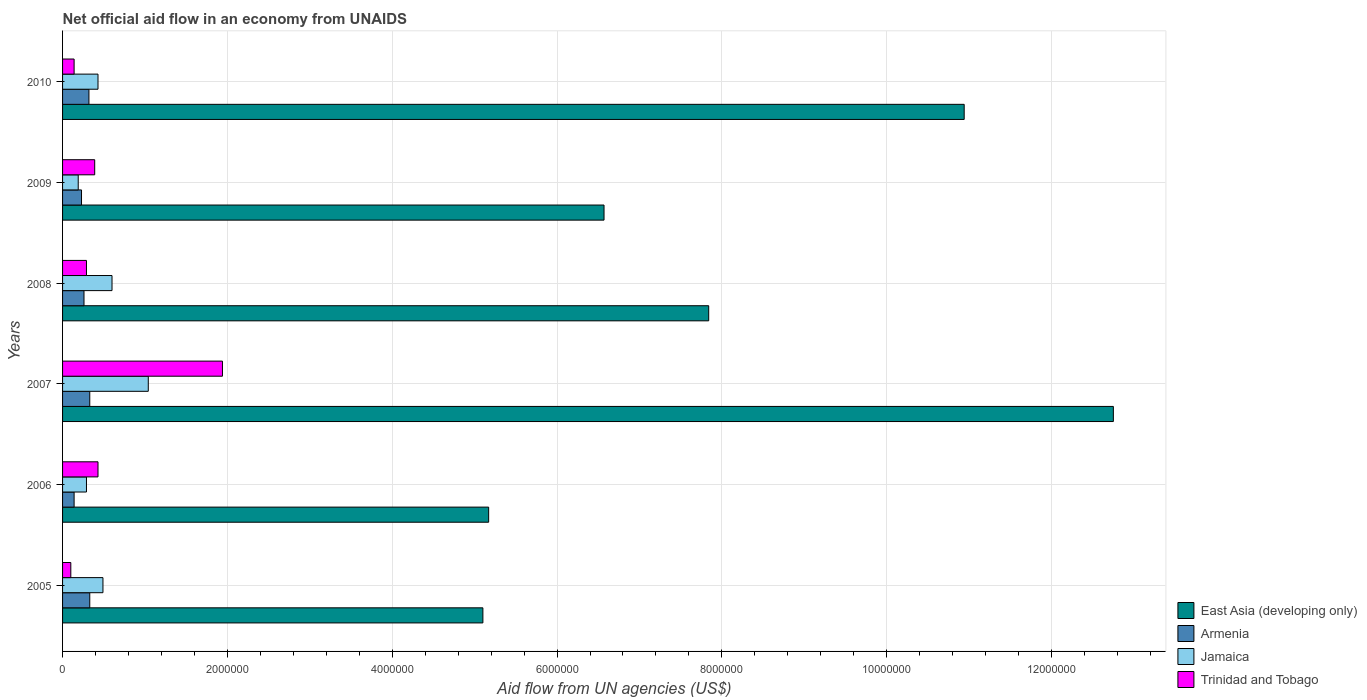How many different coloured bars are there?
Keep it short and to the point. 4. Are the number of bars per tick equal to the number of legend labels?
Provide a short and direct response. Yes. How many bars are there on the 2nd tick from the top?
Keep it short and to the point. 4. How many bars are there on the 5th tick from the bottom?
Keep it short and to the point. 4. In how many cases, is the number of bars for a given year not equal to the number of legend labels?
Your answer should be very brief. 0. Across all years, what is the maximum net official aid flow in Trinidad and Tobago?
Make the answer very short. 1.94e+06. Across all years, what is the minimum net official aid flow in Jamaica?
Provide a short and direct response. 1.90e+05. In which year was the net official aid flow in East Asia (developing only) minimum?
Provide a succinct answer. 2005. What is the total net official aid flow in Trinidad and Tobago in the graph?
Make the answer very short. 3.29e+06. What is the difference between the net official aid flow in Armenia in 2008 and that in 2010?
Provide a short and direct response. -6.00e+04. What is the difference between the net official aid flow in Jamaica in 2006 and the net official aid flow in Armenia in 2009?
Provide a short and direct response. 6.00e+04. What is the average net official aid flow in Trinidad and Tobago per year?
Make the answer very short. 5.48e+05. In the year 2010, what is the difference between the net official aid flow in Armenia and net official aid flow in East Asia (developing only)?
Your answer should be compact. -1.06e+07. In how many years, is the net official aid flow in Trinidad and Tobago greater than 6400000 US$?
Keep it short and to the point. 0. What is the ratio of the net official aid flow in East Asia (developing only) in 2006 to that in 2008?
Your answer should be very brief. 0.66. Is the net official aid flow in Armenia in 2007 less than that in 2010?
Your answer should be compact. No. Is the difference between the net official aid flow in Armenia in 2008 and 2010 greater than the difference between the net official aid flow in East Asia (developing only) in 2008 and 2010?
Give a very brief answer. Yes. What is the difference between the highest and the lowest net official aid flow in East Asia (developing only)?
Your answer should be compact. 7.65e+06. What does the 1st bar from the top in 2008 represents?
Your answer should be very brief. Trinidad and Tobago. What does the 2nd bar from the bottom in 2006 represents?
Give a very brief answer. Armenia. Is it the case that in every year, the sum of the net official aid flow in East Asia (developing only) and net official aid flow in Jamaica is greater than the net official aid flow in Trinidad and Tobago?
Provide a short and direct response. Yes. How many bars are there?
Your answer should be very brief. 24. What is the difference between two consecutive major ticks on the X-axis?
Offer a very short reply. 2.00e+06. Does the graph contain grids?
Your answer should be very brief. Yes. What is the title of the graph?
Keep it short and to the point. Net official aid flow in an economy from UNAIDS. What is the label or title of the X-axis?
Ensure brevity in your answer.  Aid flow from UN agencies (US$). What is the label or title of the Y-axis?
Your response must be concise. Years. What is the Aid flow from UN agencies (US$) in East Asia (developing only) in 2005?
Ensure brevity in your answer.  5.10e+06. What is the Aid flow from UN agencies (US$) in Armenia in 2005?
Provide a short and direct response. 3.30e+05. What is the Aid flow from UN agencies (US$) of Jamaica in 2005?
Provide a succinct answer. 4.90e+05. What is the Aid flow from UN agencies (US$) in East Asia (developing only) in 2006?
Make the answer very short. 5.17e+06. What is the Aid flow from UN agencies (US$) in Armenia in 2006?
Offer a very short reply. 1.40e+05. What is the Aid flow from UN agencies (US$) of East Asia (developing only) in 2007?
Offer a very short reply. 1.28e+07. What is the Aid flow from UN agencies (US$) in Jamaica in 2007?
Offer a very short reply. 1.04e+06. What is the Aid flow from UN agencies (US$) in Trinidad and Tobago in 2007?
Your answer should be compact. 1.94e+06. What is the Aid flow from UN agencies (US$) in East Asia (developing only) in 2008?
Your answer should be very brief. 7.84e+06. What is the Aid flow from UN agencies (US$) in Trinidad and Tobago in 2008?
Keep it short and to the point. 2.90e+05. What is the Aid flow from UN agencies (US$) of East Asia (developing only) in 2009?
Your answer should be compact. 6.57e+06. What is the Aid flow from UN agencies (US$) of Armenia in 2009?
Your answer should be very brief. 2.30e+05. What is the Aid flow from UN agencies (US$) in East Asia (developing only) in 2010?
Your answer should be compact. 1.09e+07. What is the Aid flow from UN agencies (US$) of Armenia in 2010?
Provide a short and direct response. 3.20e+05. What is the Aid flow from UN agencies (US$) of Jamaica in 2010?
Provide a succinct answer. 4.30e+05. What is the Aid flow from UN agencies (US$) of Trinidad and Tobago in 2010?
Ensure brevity in your answer.  1.40e+05. Across all years, what is the maximum Aid flow from UN agencies (US$) of East Asia (developing only)?
Give a very brief answer. 1.28e+07. Across all years, what is the maximum Aid flow from UN agencies (US$) of Jamaica?
Give a very brief answer. 1.04e+06. Across all years, what is the maximum Aid flow from UN agencies (US$) in Trinidad and Tobago?
Ensure brevity in your answer.  1.94e+06. Across all years, what is the minimum Aid flow from UN agencies (US$) in East Asia (developing only)?
Keep it short and to the point. 5.10e+06. Across all years, what is the minimum Aid flow from UN agencies (US$) of Trinidad and Tobago?
Ensure brevity in your answer.  1.00e+05. What is the total Aid flow from UN agencies (US$) in East Asia (developing only) in the graph?
Provide a succinct answer. 4.84e+07. What is the total Aid flow from UN agencies (US$) in Armenia in the graph?
Provide a succinct answer. 1.61e+06. What is the total Aid flow from UN agencies (US$) in Jamaica in the graph?
Offer a very short reply. 3.04e+06. What is the total Aid flow from UN agencies (US$) in Trinidad and Tobago in the graph?
Offer a terse response. 3.29e+06. What is the difference between the Aid flow from UN agencies (US$) in Jamaica in 2005 and that in 2006?
Your response must be concise. 2.00e+05. What is the difference between the Aid flow from UN agencies (US$) of Trinidad and Tobago in 2005 and that in 2006?
Ensure brevity in your answer.  -3.30e+05. What is the difference between the Aid flow from UN agencies (US$) of East Asia (developing only) in 2005 and that in 2007?
Offer a very short reply. -7.65e+06. What is the difference between the Aid flow from UN agencies (US$) in Armenia in 2005 and that in 2007?
Provide a succinct answer. 0. What is the difference between the Aid flow from UN agencies (US$) of Jamaica in 2005 and that in 2007?
Make the answer very short. -5.50e+05. What is the difference between the Aid flow from UN agencies (US$) in Trinidad and Tobago in 2005 and that in 2007?
Offer a very short reply. -1.84e+06. What is the difference between the Aid flow from UN agencies (US$) in East Asia (developing only) in 2005 and that in 2008?
Your answer should be very brief. -2.74e+06. What is the difference between the Aid flow from UN agencies (US$) of Armenia in 2005 and that in 2008?
Make the answer very short. 7.00e+04. What is the difference between the Aid flow from UN agencies (US$) of Trinidad and Tobago in 2005 and that in 2008?
Your response must be concise. -1.90e+05. What is the difference between the Aid flow from UN agencies (US$) of East Asia (developing only) in 2005 and that in 2009?
Provide a succinct answer. -1.47e+06. What is the difference between the Aid flow from UN agencies (US$) of Armenia in 2005 and that in 2009?
Provide a short and direct response. 1.00e+05. What is the difference between the Aid flow from UN agencies (US$) in Jamaica in 2005 and that in 2009?
Provide a succinct answer. 3.00e+05. What is the difference between the Aid flow from UN agencies (US$) of East Asia (developing only) in 2005 and that in 2010?
Give a very brief answer. -5.84e+06. What is the difference between the Aid flow from UN agencies (US$) in East Asia (developing only) in 2006 and that in 2007?
Provide a succinct answer. -7.58e+06. What is the difference between the Aid flow from UN agencies (US$) of Jamaica in 2006 and that in 2007?
Provide a succinct answer. -7.50e+05. What is the difference between the Aid flow from UN agencies (US$) in Trinidad and Tobago in 2006 and that in 2007?
Give a very brief answer. -1.51e+06. What is the difference between the Aid flow from UN agencies (US$) of East Asia (developing only) in 2006 and that in 2008?
Keep it short and to the point. -2.67e+06. What is the difference between the Aid flow from UN agencies (US$) of Jamaica in 2006 and that in 2008?
Your response must be concise. -3.10e+05. What is the difference between the Aid flow from UN agencies (US$) of East Asia (developing only) in 2006 and that in 2009?
Ensure brevity in your answer.  -1.40e+06. What is the difference between the Aid flow from UN agencies (US$) in Armenia in 2006 and that in 2009?
Your answer should be very brief. -9.00e+04. What is the difference between the Aid flow from UN agencies (US$) in Jamaica in 2006 and that in 2009?
Keep it short and to the point. 1.00e+05. What is the difference between the Aid flow from UN agencies (US$) in Trinidad and Tobago in 2006 and that in 2009?
Your response must be concise. 4.00e+04. What is the difference between the Aid flow from UN agencies (US$) of East Asia (developing only) in 2006 and that in 2010?
Make the answer very short. -5.77e+06. What is the difference between the Aid flow from UN agencies (US$) of Jamaica in 2006 and that in 2010?
Keep it short and to the point. -1.40e+05. What is the difference between the Aid flow from UN agencies (US$) of Trinidad and Tobago in 2006 and that in 2010?
Your answer should be very brief. 2.90e+05. What is the difference between the Aid flow from UN agencies (US$) of East Asia (developing only) in 2007 and that in 2008?
Ensure brevity in your answer.  4.91e+06. What is the difference between the Aid flow from UN agencies (US$) of Armenia in 2007 and that in 2008?
Offer a very short reply. 7.00e+04. What is the difference between the Aid flow from UN agencies (US$) of Trinidad and Tobago in 2007 and that in 2008?
Ensure brevity in your answer.  1.65e+06. What is the difference between the Aid flow from UN agencies (US$) of East Asia (developing only) in 2007 and that in 2009?
Make the answer very short. 6.18e+06. What is the difference between the Aid flow from UN agencies (US$) of Jamaica in 2007 and that in 2009?
Your response must be concise. 8.50e+05. What is the difference between the Aid flow from UN agencies (US$) of Trinidad and Tobago in 2007 and that in 2009?
Your answer should be compact. 1.55e+06. What is the difference between the Aid flow from UN agencies (US$) of East Asia (developing only) in 2007 and that in 2010?
Your answer should be very brief. 1.81e+06. What is the difference between the Aid flow from UN agencies (US$) of Armenia in 2007 and that in 2010?
Make the answer very short. 10000. What is the difference between the Aid flow from UN agencies (US$) in Jamaica in 2007 and that in 2010?
Keep it short and to the point. 6.10e+05. What is the difference between the Aid flow from UN agencies (US$) in Trinidad and Tobago in 2007 and that in 2010?
Offer a terse response. 1.80e+06. What is the difference between the Aid flow from UN agencies (US$) in East Asia (developing only) in 2008 and that in 2009?
Offer a terse response. 1.27e+06. What is the difference between the Aid flow from UN agencies (US$) in East Asia (developing only) in 2008 and that in 2010?
Your response must be concise. -3.10e+06. What is the difference between the Aid flow from UN agencies (US$) of Armenia in 2008 and that in 2010?
Give a very brief answer. -6.00e+04. What is the difference between the Aid flow from UN agencies (US$) of Trinidad and Tobago in 2008 and that in 2010?
Provide a succinct answer. 1.50e+05. What is the difference between the Aid flow from UN agencies (US$) of East Asia (developing only) in 2009 and that in 2010?
Provide a short and direct response. -4.37e+06. What is the difference between the Aid flow from UN agencies (US$) in Armenia in 2009 and that in 2010?
Ensure brevity in your answer.  -9.00e+04. What is the difference between the Aid flow from UN agencies (US$) in Trinidad and Tobago in 2009 and that in 2010?
Keep it short and to the point. 2.50e+05. What is the difference between the Aid flow from UN agencies (US$) of East Asia (developing only) in 2005 and the Aid flow from UN agencies (US$) of Armenia in 2006?
Provide a succinct answer. 4.96e+06. What is the difference between the Aid flow from UN agencies (US$) in East Asia (developing only) in 2005 and the Aid flow from UN agencies (US$) in Jamaica in 2006?
Offer a terse response. 4.81e+06. What is the difference between the Aid flow from UN agencies (US$) in East Asia (developing only) in 2005 and the Aid flow from UN agencies (US$) in Trinidad and Tobago in 2006?
Your answer should be compact. 4.67e+06. What is the difference between the Aid flow from UN agencies (US$) in Armenia in 2005 and the Aid flow from UN agencies (US$) in Jamaica in 2006?
Provide a short and direct response. 4.00e+04. What is the difference between the Aid flow from UN agencies (US$) in East Asia (developing only) in 2005 and the Aid flow from UN agencies (US$) in Armenia in 2007?
Your response must be concise. 4.77e+06. What is the difference between the Aid flow from UN agencies (US$) in East Asia (developing only) in 2005 and the Aid flow from UN agencies (US$) in Jamaica in 2007?
Your answer should be compact. 4.06e+06. What is the difference between the Aid flow from UN agencies (US$) in East Asia (developing only) in 2005 and the Aid flow from UN agencies (US$) in Trinidad and Tobago in 2007?
Your answer should be very brief. 3.16e+06. What is the difference between the Aid flow from UN agencies (US$) of Armenia in 2005 and the Aid flow from UN agencies (US$) of Jamaica in 2007?
Your answer should be very brief. -7.10e+05. What is the difference between the Aid flow from UN agencies (US$) of Armenia in 2005 and the Aid flow from UN agencies (US$) of Trinidad and Tobago in 2007?
Your answer should be very brief. -1.61e+06. What is the difference between the Aid flow from UN agencies (US$) in Jamaica in 2005 and the Aid flow from UN agencies (US$) in Trinidad and Tobago in 2007?
Offer a very short reply. -1.45e+06. What is the difference between the Aid flow from UN agencies (US$) of East Asia (developing only) in 2005 and the Aid flow from UN agencies (US$) of Armenia in 2008?
Your response must be concise. 4.84e+06. What is the difference between the Aid flow from UN agencies (US$) in East Asia (developing only) in 2005 and the Aid flow from UN agencies (US$) in Jamaica in 2008?
Offer a very short reply. 4.50e+06. What is the difference between the Aid flow from UN agencies (US$) in East Asia (developing only) in 2005 and the Aid flow from UN agencies (US$) in Trinidad and Tobago in 2008?
Ensure brevity in your answer.  4.81e+06. What is the difference between the Aid flow from UN agencies (US$) of East Asia (developing only) in 2005 and the Aid flow from UN agencies (US$) of Armenia in 2009?
Offer a very short reply. 4.87e+06. What is the difference between the Aid flow from UN agencies (US$) in East Asia (developing only) in 2005 and the Aid flow from UN agencies (US$) in Jamaica in 2009?
Provide a succinct answer. 4.91e+06. What is the difference between the Aid flow from UN agencies (US$) of East Asia (developing only) in 2005 and the Aid flow from UN agencies (US$) of Trinidad and Tobago in 2009?
Keep it short and to the point. 4.71e+06. What is the difference between the Aid flow from UN agencies (US$) in Armenia in 2005 and the Aid flow from UN agencies (US$) in Trinidad and Tobago in 2009?
Keep it short and to the point. -6.00e+04. What is the difference between the Aid flow from UN agencies (US$) of East Asia (developing only) in 2005 and the Aid flow from UN agencies (US$) of Armenia in 2010?
Offer a terse response. 4.78e+06. What is the difference between the Aid flow from UN agencies (US$) of East Asia (developing only) in 2005 and the Aid flow from UN agencies (US$) of Jamaica in 2010?
Offer a very short reply. 4.67e+06. What is the difference between the Aid flow from UN agencies (US$) of East Asia (developing only) in 2005 and the Aid flow from UN agencies (US$) of Trinidad and Tobago in 2010?
Your response must be concise. 4.96e+06. What is the difference between the Aid flow from UN agencies (US$) of East Asia (developing only) in 2006 and the Aid flow from UN agencies (US$) of Armenia in 2007?
Ensure brevity in your answer.  4.84e+06. What is the difference between the Aid flow from UN agencies (US$) of East Asia (developing only) in 2006 and the Aid flow from UN agencies (US$) of Jamaica in 2007?
Offer a terse response. 4.13e+06. What is the difference between the Aid flow from UN agencies (US$) in East Asia (developing only) in 2006 and the Aid flow from UN agencies (US$) in Trinidad and Tobago in 2007?
Your response must be concise. 3.23e+06. What is the difference between the Aid flow from UN agencies (US$) of Armenia in 2006 and the Aid flow from UN agencies (US$) of Jamaica in 2007?
Make the answer very short. -9.00e+05. What is the difference between the Aid flow from UN agencies (US$) in Armenia in 2006 and the Aid flow from UN agencies (US$) in Trinidad and Tobago in 2007?
Keep it short and to the point. -1.80e+06. What is the difference between the Aid flow from UN agencies (US$) of Jamaica in 2006 and the Aid flow from UN agencies (US$) of Trinidad and Tobago in 2007?
Offer a terse response. -1.65e+06. What is the difference between the Aid flow from UN agencies (US$) of East Asia (developing only) in 2006 and the Aid flow from UN agencies (US$) of Armenia in 2008?
Your answer should be compact. 4.91e+06. What is the difference between the Aid flow from UN agencies (US$) of East Asia (developing only) in 2006 and the Aid flow from UN agencies (US$) of Jamaica in 2008?
Make the answer very short. 4.57e+06. What is the difference between the Aid flow from UN agencies (US$) in East Asia (developing only) in 2006 and the Aid flow from UN agencies (US$) in Trinidad and Tobago in 2008?
Make the answer very short. 4.88e+06. What is the difference between the Aid flow from UN agencies (US$) of Armenia in 2006 and the Aid flow from UN agencies (US$) of Jamaica in 2008?
Make the answer very short. -4.60e+05. What is the difference between the Aid flow from UN agencies (US$) of East Asia (developing only) in 2006 and the Aid flow from UN agencies (US$) of Armenia in 2009?
Your response must be concise. 4.94e+06. What is the difference between the Aid flow from UN agencies (US$) of East Asia (developing only) in 2006 and the Aid flow from UN agencies (US$) of Jamaica in 2009?
Give a very brief answer. 4.98e+06. What is the difference between the Aid flow from UN agencies (US$) in East Asia (developing only) in 2006 and the Aid flow from UN agencies (US$) in Trinidad and Tobago in 2009?
Keep it short and to the point. 4.78e+06. What is the difference between the Aid flow from UN agencies (US$) in Jamaica in 2006 and the Aid flow from UN agencies (US$) in Trinidad and Tobago in 2009?
Offer a very short reply. -1.00e+05. What is the difference between the Aid flow from UN agencies (US$) of East Asia (developing only) in 2006 and the Aid flow from UN agencies (US$) of Armenia in 2010?
Keep it short and to the point. 4.85e+06. What is the difference between the Aid flow from UN agencies (US$) in East Asia (developing only) in 2006 and the Aid flow from UN agencies (US$) in Jamaica in 2010?
Your response must be concise. 4.74e+06. What is the difference between the Aid flow from UN agencies (US$) of East Asia (developing only) in 2006 and the Aid flow from UN agencies (US$) of Trinidad and Tobago in 2010?
Keep it short and to the point. 5.03e+06. What is the difference between the Aid flow from UN agencies (US$) in Armenia in 2006 and the Aid flow from UN agencies (US$) in Jamaica in 2010?
Your answer should be very brief. -2.90e+05. What is the difference between the Aid flow from UN agencies (US$) of East Asia (developing only) in 2007 and the Aid flow from UN agencies (US$) of Armenia in 2008?
Provide a short and direct response. 1.25e+07. What is the difference between the Aid flow from UN agencies (US$) of East Asia (developing only) in 2007 and the Aid flow from UN agencies (US$) of Jamaica in 2008?
Keep it short and to the point. 1.22e+07. What is the difference between the Aid flow from UN agencies (US$) in East Asia (developing only) in 2007 and the Aid flow from UN agencies (US$) in Trinidad and Tobago in 2008?
Ensure brevity in your answer.  1.25e+07. What is the difference between the Aid flow from UN agencies (US$) of Armenia in 2007 and the Aid flow from UN agencies (US$) of Trinidad and Tobago in 2008?
Your response must be concise. 4.00e+04. What is the difference between the Aid flow from UN agencies (US$) in Jamaica in 2007 and the Aid flow from UN agencies (US$) in Trinidad and Tobago in 2008?
Provide a succinct answer. 7.50e+05. What is the difference between the Aid flow from UN agencies (US$) of East Asia (developing only) in 2007 and the Aid flow from UN agencies (US$) of Armenia in 2009?
Your answer should be compact. 1.25e+07. What is the difference between the Aid flow from UN agencies (US$) in East Asia (developing only) in 2007 and the Aid flow from UN agencies (US$) in Jamaica in 2009?
Your response must be concise. 1.26e+07. What is the difference between the Aid flow from UN agencies (US$) of East Asia (developing only) in 2007 and the Aid flow from UN agencies (US$) of Trinidad and Tobago in 2009?
Your answer should be compact. 1.24e+07. What is the difference between the Aid flow from UN agencies (US$) of Armenia in 2007 and the Aid flow from UN agencies (US$) of Jamaica in 2009?
Offer a terse response. 1.40e+05. What is the difference between the Aid flow from UN agencies (US$) of Armenia in 2007 and the Aid flow from UN agencies (US$) of Trinidad and Tobago in 2009?
Ensure brevity in your answer.  -6.00e+04. What is the difference between the Aid flow from UN agencies (US$) in Jamaica in 2007 and the Aid flow from UN agencies (US$) in Trinidad and Tobago in 2009?
Keep it short and to the point. 6.50e+05. What is the difference between the Aid flow from UN agencies (US$) of East Asia (developing only) in 2007 and the Aid flow from UN agencies (US$) of Armenia in 2010?
Your response must be concise. 1.24e+07. What is the difference between the Aid flow from UN agencies (US$) in East Asia (developing only) in 2007 and the Aid flow from UN agencies (US$) in Jamaica in 2010?
Provide a short and direct response. 1.23e+07. What is the difference between the Aid flow from UN agencies (US$) in East Asia (developing only) in 2007 and the Aid flow from UN agencies (US$) in Trinidad and Tobago in 2010?
Give a very brief answer. 1.26e+07. What is the difference between the Aid flow from UN agencies (US$) of Jamaica in 2007 and the Aid flow from UN agencies (US$) of Trinidad and Tobago in 2010?
Your answer should be very brief. 9.00e+05. What is the difference between the Aid flow from UN agencies (US$) of East Asia (developing only) in 2008 and the Aid flow from UN agencies (US$) of Armenia in 2009?
Make the answer very short. 7.61e+06. What is the difference between the Aid flow from UN agencies (US$) in East Asia (developing only) in 2008 and the Aid flow from UN agencies (US$) in Jamaica in 2009?
Provide a short and direct response. 7.65e+06. What is the difference between the Aid flow from UN agencies (US$) of East Asia (developing only) in 2008 and the Aid flow from UN agencies (US$) of Trinidad and Tobago in 2009?
Keep it short and to the point. 7.45e+06. What is the difference between the Aid flow from UN agencies (US$) in Armenia in 2008 and the Aid flow from UN agencies (US$) in Jamaica in 2009?
Make the answer very short. 7.00e+04. What is the difference between the Aid flow from UN agencies (US$) of East Asia (developing only) in 2008 and the Aid flow from UN agencies (US$) of Armenia in 2010?
Keep it short and to the point. 7.52e+06. What is the difference between the Aid flow from UN agencies (US$) in East Asia (developing only) in 2008 and the Aid flow from UN agencies (US$) in Jamaica in 2010?
Your answer should be compact. 7.41e+06. What is the difference between the Aid flow from UN agencies (US$) in East Asia (developing only) in 2008 and the Aid flow from UN agencies (US$) in Trinidad and Tobago in 2010?
Your response must be concise. 7.70e+06. What is the difference between the Aid flow from UN agencies (US$) in Armenia in 2008 and the Aid flow from UN agencies (US$) in Jamaica in 2010?
Offer a terse response. -1.70e+05. What is the difference between the Aid flow from UN agencies (US$) in Jamaica in 2008 and the Aid flow from UN agencies (US$) in Trinidad and Tobago in 2010?
Keep it short and to the point. 4.60e+05. What is the difference between the Aid flow from UN agencies (US$) in East Asia (developing only) in 2009 and the Aid flow from UN agencies (US$) in Armenia in 2010?
Provide a succinct answer. 6.25e+06. What is the difference between the Aid flow from UN agencies (US$) in East Asia (developing only) in 2009 and the Aid flow from UN agencies (US$) in Jamaica in 2010?
Offer a very short reply. 6.14e+06. What is the difference between the Aid flow from UN agencies (US$) in East Asia (developing only) in 2009 and the Aid flow from UN agencies (US$) in Trinidad and Tobago in 2010?
Ensure brevity in your answer.  6.43e+06. What is the difference between the Aid flow from UN agencies (US$) in Armenia in 2009 and the Aid flow from UN agencies (US$) in Jamaica in 2010?
Your answer should be compact. -2.00e+05. What is the difference between the Aid flow from UN agencies (US$) of Jamaica in 2009 and the Aid flow from UN agencies (US$) of Trinidad and Tobago in 2010?
Provide a succinct answer. 5.00e+04. What is the average Aid flow from UN agencies (US$) of East Asia (developing only) per year?
Give a very brief answer. 8.06e+06. What is the average Aid flow from UN agencies (US$) in Armenia per year?
Provide a short and direct response. 2.68e+05. What is the average Aid flow from UN agencies (US$) of Jamaica per year?
Offer a terse response. 5.07e+05. What is the average Aid flow from UN agencies (US$) in Trinidad and Tobago per year?
Offer a terse response. 5.48e+05. In the year 2005, what is the difference between the Aid flow from UN agencies (US$) in East Asia (developing only) and Aid flow from UN agencies (US$) in Armenia?
Give a very brief answer. 4.77e+06. In the year 2005, what is the difference between the Aid flow from UN agencies (US$) of East Asia (developing only) and Aid flow from UN agencies (US$) of Jamaica?
Give a very brief answer. 4.61e+06. In the year 2005, what is the difference between the Aid flow from UN agencies (US$) of Armenia and Aid flow from UN agencies (US$) of Jamaica?
Offer a very short reply. -1.60e+05. In the year 2006, what is the difference between the Aid flow from UN agencies (US$) in East Asia (developing only) and Aid flow from UN agencies (US$) in Armenia?
Provide a short and direct response. 5.03e+06. In the year 2006, what is the difference between the Aid flow from UN agencies (US$) in East Asia (developing only) and Aid flow from UN agencies (US$) in Jamaica?
Make the answer very short. 4.88e+06. In the year 2006, what is the difference between the Aid flow from UN agencies (US$) of East Asia (developing only) and Aid flow from UN agencies (US$) of Trinidad and Tobago?
Your response must be concise. 4.74e+06. In the year 2006, what is the difference between the Aid flow from UN agencies (US$) of Armenia and Aid flow from UN agencies (US$) of Trinidad and Tobago?
Your answer should be compact. -2.90e+05. In the year 2007, what is the difference between the Aid flow from UN agencies (US$) in East Asia (developing only) and Aid flow from UN agencies (US$) in Armenia?
Offer a very short reply. 1.24e+07. In the year 2007, what is the difference between the Aid flow from UN agencies (US$) of East Asia (developing only) and Aid flow from UN agencies (US$) of Jamaica?
Your answer should be compact. 1.17e+07. In the year 2007, what is the difference between the Aid flow from UN agencies (US$) of East Asia (developing only) and Aid flow from UN agencies (US$) of Trinidad and Tobago?
Make the answer very short. 1.08e+07. In the year 2007, what is the difference between the Aid flow from UN agencies (US$) of Armenia and Aid flow from UN agencies (US$) of Jamaica?
Make the answer very short. -7.10e+05. In the year 2007, what is the difference between the Aid flow from UN agencies (US$) of Armenia and Aid flow from UN agencies (US$) of Trinidad and Tobago?
Offer a very short reply. -1.61e+06. In the year 2007, what is the difference between the Aid flow from UN agencies (US$) of Jamaica and Aid flow from UN agencies (US$) of Trinidad and Tobago?
Give a very brief answer. -9.00e+05. In the year 2008, what is the difference between the Aid flow from UN agencies (US$) of East Asia (developing only) and Aid flow from UN agencies (US$) of Armenia?
Provide a short and direct response. 7.58e+06. In the year 2008, what is the difference between the Aid flow from UN agencies (US$) of East Asia (developing only) and Aid flow from UN agencies (US$) of Jamaica?
Provide a succinct answer. 7.24e+06. In the year 2008, what is the difference between the Aid flow from UN agencies (US$) of East Asia (developing only) and Aid flow from UN agencies (US$) of Trinidad and Tobago?
Make the answer very short. 7.55e+06. In the year 2008, what is the difference between the Aid flow from UN agencies (US$) in Armenia and Aid flow from UN agencies (US$) in Jamaica?
Offer a very short reply. -3.40e+05. In the year 2009, what is the difference between the Aid flow from UN agencies (US$) of East Asia (developing only) and Aid flow from UN agencies (US$) of Armenia?
Ensure brevity in your answer.  6.34e+06. In the year 2009, what is the difference between the Aid flow from UN agencies (US$) of East Asia (developing only) and Aid flow from UN agencies (US$) of Jamaica?
Your response must be concise. 6.38e+06. In the year 2009, what is the difference between the Aid flow from UN agencies (US$) in East Asia (developing only) and Aid flow from UN agencies (US$) in Trinidad and Tobago?
Keep it short and to the point. 6.18e+06. In the year 2009, what is the difference between the Aid flow from UN agencies (US$) in Armenia and Aid flow from UN agencies (US$) in Jamaica?
Provide a short and direct response. 4.00e+04. In the year 2009, what is the difference between the Aid flow from UN agencies (US$) of Jamaica and Aid flow from UN agencies (US$) of Trinidad and Tobago?
Ensure brevity in your answer.  -2.00e+05. In the year 2010, what is the difference between the Aid flow from UN agencies (US$) of East Asia (developing only) and Aid flow from UN agencies (US$) of Armenia?
Make the answer very short. 1.06e+07. In the year 2010, what is the difference between the Aid flow from UN agencies (US$) of East Asia (developing only) and Aid flow from UN agencies (US$) of Jamaica?
Offer a very short reply. 1.05e+07. In the year 2010, what is the difference between the Aid flow from UN agencies (US$) in East Asia (developing only) and Aid flow from UN agencies (US$) in Trinidad and Tobago?
Ensure brevity in your answer.  1.08e+07. In the year 2010, what is the difference between the Aid flow from UN agencies (US$) of Armenia and Aid flow from UN agencies (US$) of Jamaica?
Give a very brief answer. -1.10e+05. In the year 2010, what is the difference between the Aid flow from UN agencies (US$) in Jamaica and Aid flow from UN agencies (US$) in Trinidad and Tobago?
Give a very brief answer. 2.90e+05. What is the ratio of the Aid flow from UN agencies (US$) of East Asia (developing only) in 2005 to that in 2006?
Keep it short and to the point. 0.99. What is the ratio of the Aid flow from UN agencies (US$) in Armenia in 2005 to that in 2006?
Your answer should be very brief. 2.36. What is the ratio of the Aid flow from UN agencies (US$) in Jamaica in 2005 to that in 2006?
Keep it short and to the point. 1.69. What is the ratio of the Aid flow from UN agencies (US$) of Trinidad and Tobago in 2005 to that in 2006?
Offer a terse response. 0.23. What is the ratio of the Aid flow from UN agencies (US$) of Jamaica in 2005 to that in 2007?
Offer a very short reply. 0.47. What is the ratio of the Aid flow from UN agencies (US$) of Trinidad and Tobago in 2005 to that in 2007?
Your answer should be compact. 0.05. What is the ratio of the Aid flow from UN agencies (US$) of East Asia (developing only) in 2005 to that in 2008?
Your answer should be very brief. 0.65. What is the ratio of the Aid flow from UN agencies (US$) in Armenia in 2005 to that in 2008?
Your response must be concise. 1.27. What is the ratio of the Aid flow from UN agencies (US$) in Jamaica in 2005 to that in 2008?
Keep it short and to the point. 0.82. What is the ratio of the Aid flow from UN agencies (US$) of Trinidad and Tobago in 2005 to that in 2008?
Keep it short and to the point. 0.34. What is the ratio of the Aid flow from UN agencies (US$) in East Asia (developing only) in 2005 to that in 2009?
Make the answer very short. 0.78. What is the ratio of the Aid flow from UN agencies (US$) in Armenia in 2005 to that in 2009?
Ensure brevity in your answer.  1.43. What is the ratio of the Aid flow from UN agencies (US$) in Jamaica in 2005 to that in 2009?
Provide a short and direct response. 2.58. What is the ratio of the Aid flow from UN agencies (US$) of Trinidad and Tobago in 2005 to that in 2009?
Ensure brevity in your answer.  0.26. What is the ratio of the Aid flow from UN agencies (US$) of East Asia (developing only) in 2005 to that in 2010?
Provide a succinct answer. 0.47. What is the ratio of the Aid flow from UN agencies (US$) in Armenia in 2005 to that in 2010?
Provide a succinct answer. 1.03. What is the ratio of the Aid flow from UN agencies (US$) of Jamaica in 2005 to that in 2010?
Offer a very short reply. 1.14. What is the ratio of the Aid flow from UN agencies (US$) in East Asia (developing only) in 2006 to that in 2007?
Provide a short and direct response. 0.41. What is the ratio of the Aid flow from UN agencies (US$) in Armenia in 2006 to that in 2007?
Keep it short and to the point. 0.42. What is the ratio of the Aid flow from UN agencies (US$) of Jamaica in 2006 to that in 2007?
Offer a terse response. 0.28. What is the ratio of the Aid flow from UN agencies (US$) of Trinidad and Tobago in 2006 to that in 2007?
Your response must be concise. 0.22. What is the ratio of the Aid flow from UN agencies (US$) in East Asia (developing only) in 2006 to that in 2008?
Provide a succinct answer. 0.66. What is the ratio of the Aid flow from UN agencies (US$) of Armenia in 2006 to that in 2008?
Ensure brevity in your answer.  0.54. What is the ratio of the Aid flow from UN agencies (US$) in Jamaica in 2006 to that in 2008?
Keep it short and to the point. 0.48. What is the ratio of the Aid flow from UN agencies (US$) in Trinidad and Tobago in 2006 to that in 2008?
Offer a terse response. 1.48. What is the ratio of the Aid flow from UN agencies (US$) in East Asia (developing only) in 2006 to that in 2009?
Provide a succinct answer. 0.79. What is the ratio of the Aid flow from UN agencies (US$) in Armenia in 2006 to that in 2009?
Keep it short and to the point. 0.61. What is the ratio of the Aid flow from UN agencies (US$) in Jamaica in 2006 to that in 2009?
Provide a short and direct response. 1.53. What is the ratio of the Aid flow from UN agencies (US$) of Trinidad and Tobago in 2006 to that in 2009?
Offer a terse response. 1.1. What is the ratio of the Aid flow from UN agencies (US$) in East Asia (developing only) in 2006 to that in 2010?
Give a very brief answer. 0.47. What is the ratio of the Aid flow from UN agencies (US$) of Armenia in 2006 to that in 2010?
Provide a short and direct response. 0.44. What is the ratio of the Aid flow from UN agencies (US$) in Jamaica in 2006 to that in 2010?
Your response must be concise. 0.67. What is the ratio of the Aid flow from UN agencies (US$) in Trinidad and Tobago in 2006 to that in 2010?
Provide a succinct answer. 3.07. What is the ratio of the Aid flow from UN agencies (US$) of East Asia (developing only) in 2007 to that in 2008?
Your answer should be very brief. 1.63. What is the ratio of the Aid flow from UN agencies (US$) of Armenia in 2007 to that in 2008?
Offer a terse response. 1.27. What is the ratio of the Aid flow from UN agencies (US$) in Jamaica in 2007 to that in 2008?
Keep it short and to the point. 1.73. What is the ratio of the Aid flow from UN agencies (US$) in Trinidad and Tobago in 2007 to that in 2008?
Offer a terse response. 6.69. What is the ratio of the Aid flow from UN agencies (US$) of East Asia (developing only) in 2007 to that in 2009?
Offer a terse response. 1.94. What is the ratio of the Aid flow from UN agencies (US$) of Armenia in 2007 to that in 2009?
Your response must be concise. 1.43. What is the ratio of the Aid flow from UN agencies (US$) of Jamaica in 2007 to that in 2009?
Give a very brief answer. 5.47. What is the ratio of the Aid flow from UN agencies (US$) of Trinidad and Tobago in 2007 to that in 2009?
Your answer should be very brief. 4.97. What is the ratio of the Aid flow from UN agencies (US$) in East Asia (developing only) in 2007 to that in 2010?
Keep it short and to the point. 1.17. What is the ratio of the Aid flow from UN agencies (US$) of Armenia in 2007 to that in 2010?
Your response must be concise. 1.03. What is the ratio of the Aid flow from UN agencies (US$) in Jamaica in 2007 to that in 2010?
Your answer should be compact. 2.42. What is the ratio of the Aid flow from UN agencies (US$) in Trinidad and Tobago in 2007 to that in 2010?
Ensure brevity in your answer.  13.86. What is the ratio of the Aid flow from UN agencies (US$) in East Asia (developing only) in 2008 to that in 2009?
Provide a short and direct response. 1.19. What is the ratio of the Aid flow from UN agencies (US$) of Armenia in 2008 to that in 2009?
Your answer should be compact. 1.13. What is the ratio of the Aid flow from UN agencies (US$) in Jamaica in 2008 to that in 2009?
Provide a short and direct response. 3.16. What is the ratio of the Aid flow from UN agencies (US$) in Trinidad and Tobago in 2008 to that in 2009?
Your response must be concise. 0.74. What is the ratio of the Aid flow from UN agencies (US$) of East Asia (developing only) in 2008 to that in 2010?
Your answer should be compact. 0.72. What is the ratio of the Aid flow from UN agencies (US$) of Armenia in 2008 to that in 2010?
Offer a terse response. 0.81. What is the ratio of the Aid flow from UN agencies (US$) of Jamaica in 2008 to that in 2010?
Your answer should be very brief. 1.4. What is the ratio of the Aid flow from UN agencies (US$) of Trinidad and Tobago in 2008 to that in 2010?
Offer a very short reply. 2.07. What is the ratio of the Aid flow from UN agencies (US$) of East Asia (developing only) in 2009 to that in 2010?
Offer a terse response. 0.6. What is the ratio of the Aid flow from UN agencies (US$) in Armenia in 2009 to that in 2010?
Give a very brief answer. 0.72. What is the ratio of the Aid flow from UN agencies (US$) in Jamaica in 2009 to that in 2010?
Make the answer very short. 0.44. What is the ratio of the Aid flow from UN agencies (US$) of Trinidad and Tobago in 2009 to that in 2010?
Provide a succinct answer. 2.79. What is the difference between the highest and the second highest Aid flow from UN agencies (US$) in East Asia (developing only)?
Offer a terse response. 1.81e+06. What is the difference between the highest and the second highest Aid flow from UN agencies (US$) of Jamaica?
Make the answer very short. 4.40e+05. What is the difference between the highest and the second highest Aid flow from UN agencies (US$) in Trinidad and Tobago?
Give a very brief answer. 1.51e+06. What is the difference between the highest and the lowest Aid flow from UN agencies (US$) of East Asia (developing only)?
Offer a very short reply. 7.65e+06. What is the difference between the highest and the lowest Aid flow from UN agencies (US$) in Armenia?
Your response must be concise. 1.90e+05. What is the difference between the highest and the lowest Aid flow from UN agencies (US$) of Jamaica?
Offer a terse response. 8.50e+05. What is the difference between the highest and the lowest Aid flow from UN agencies (US$) in Trinidad and Tobago?
Your answer should be very brief. 1.84e+06. 